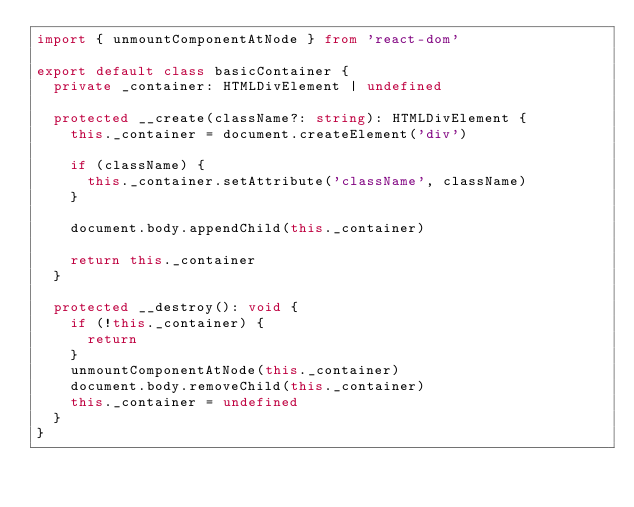<code> <loc_0><loc_0><loc_500><loc_500><_TypeScript_>import { unmountComponentAtNode } from 'react-dom'

export default class basicContainer {
  private _container: HTMLDivElement | undefined

  protected __create(className?: string): HTMLDivElement {
    this._container = document.createElement('div')

    if (className) {
      this._container.setAttribute('className', className)
    }

    document.body.appendChild(this._container)

    return this._container
  }

  protected __destroy(): void {
    if (!this._container) {
      return
    }
    unmountComponentAtNode(this._container)
    document.body.removeChild(this._container)
    this._container = undefined
  }
}
</code> 